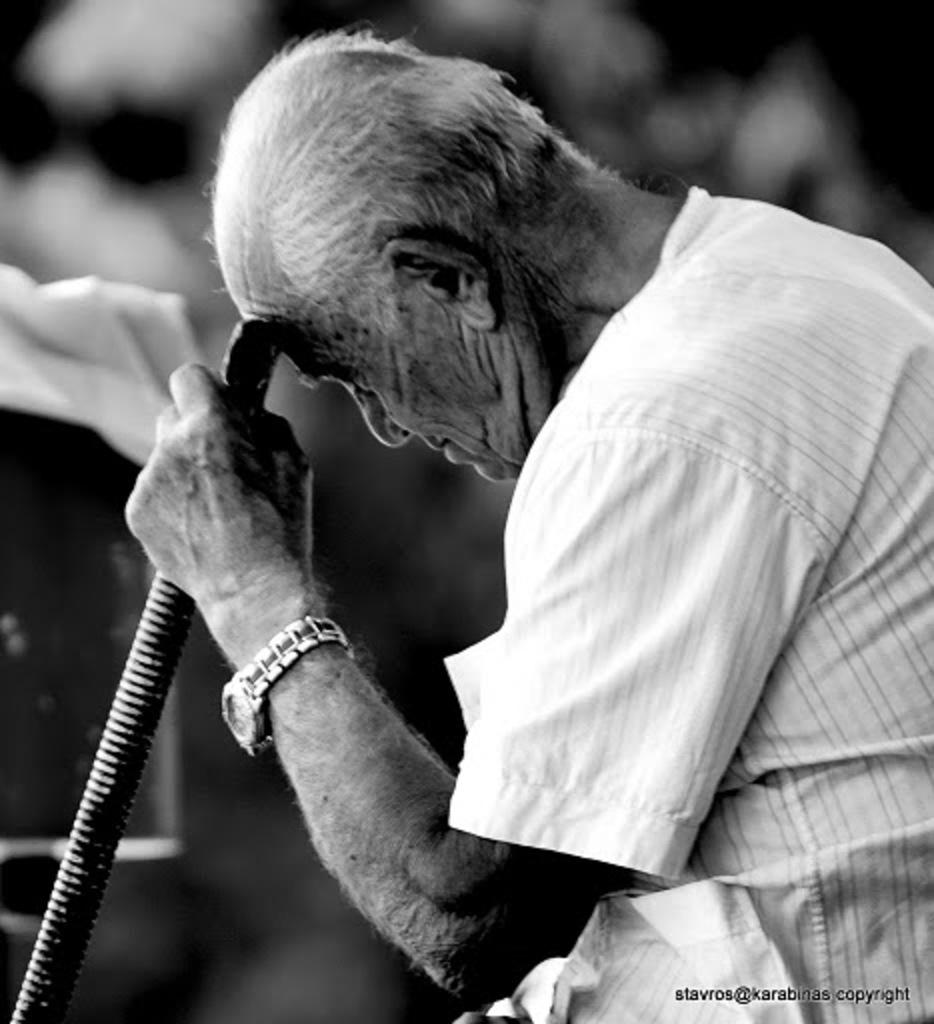What is the main subject of the image? The main subject of the image is a man. What is the man wearing? The man is wearing a white shirt. What accessory is the man wearing on his wrist? The man is wearing a watch. What object is the man holding in the image? The man is holding a stick. How would you describe the background of the image? The background of the image is dark. What type of knife is the man using to cut the glue in the image? There is no knife or glue present in the image. The man is holding a stick, and there is no indication of cutting or glue in the image. 